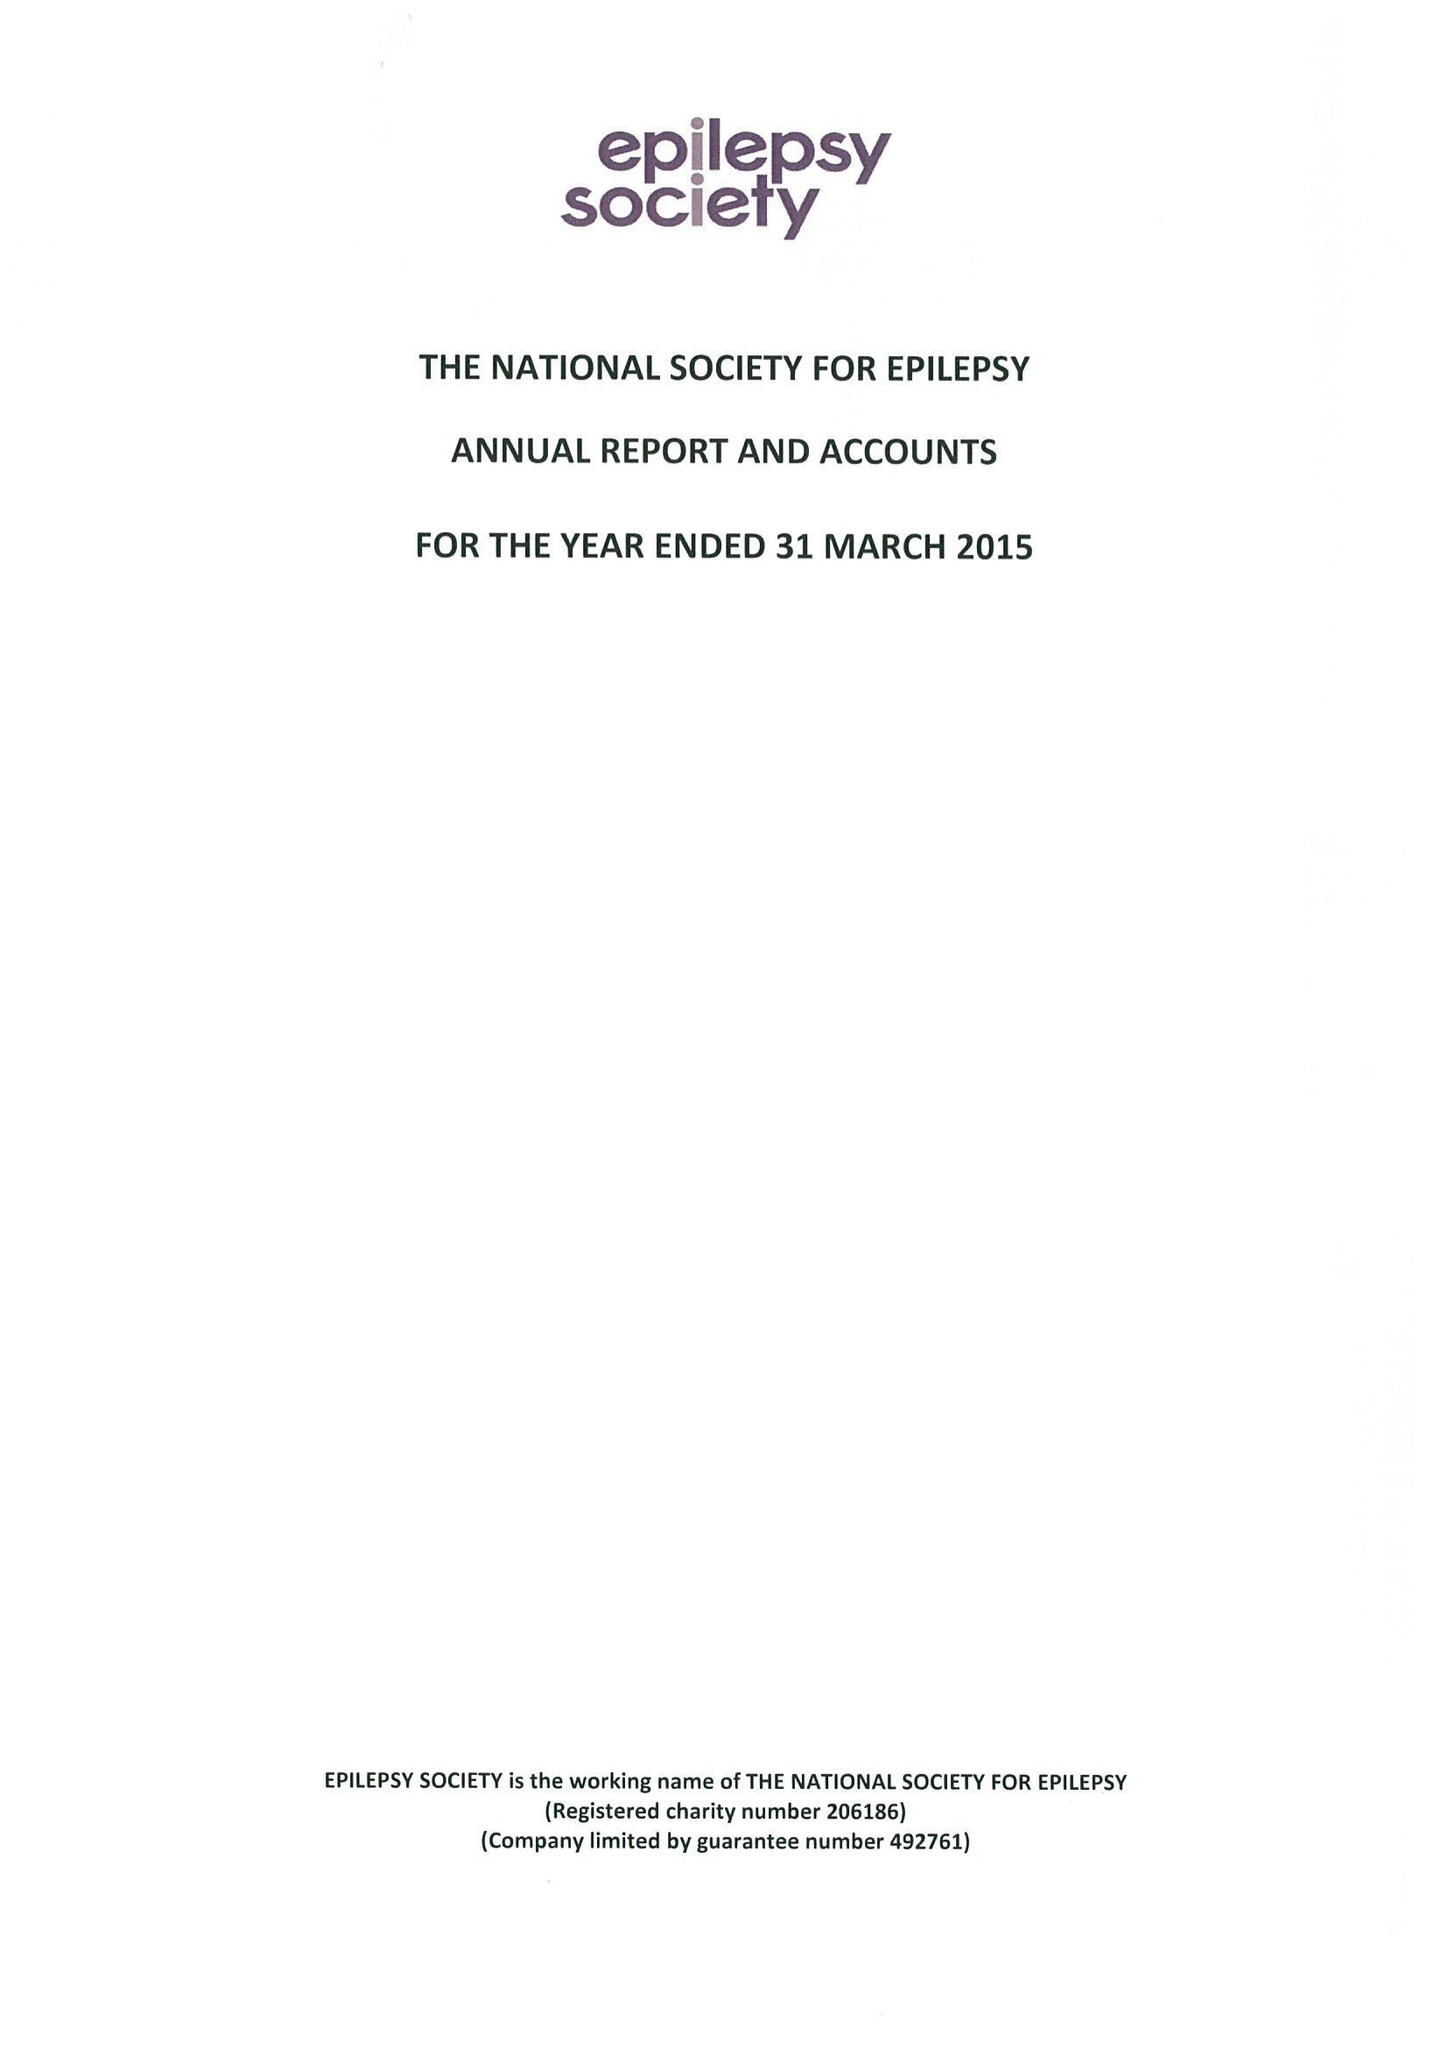What is the value for the address__postcode?
Answer the question using a single word or phrase. SL9 0RJ 